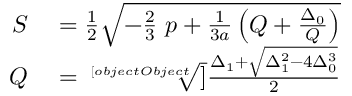Convert formula to latex. <formula><loc_0><loc_0><loc_500><loc_500>\begin{array} { r l } { S } & = { \frac { 1 } { 2 } } { \sqrt { - { \frac { 2 } { 3 } } \ p + { \frac { 1 } { 3 a } } \left ( Q + { \frac { \Delta _ { 0 } } { Q } } \right ) } } } \\ { Q } & = { \sqrt { [ } [ o b j e c t O b j e c t ] ] { \frac { \Delta _ { 1 } + { \sqrt { \Delta _ { 1 } ^ { 2 } - 4 \Delta _ { 0 } ^ { 3 } } } } { 2 } } } } \end{array}</formula> 